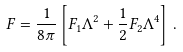<formula> <loc_0><loc_0><loc_500><loc_500>F = \frac { 1 } { 8 \pi } \left [ F _ { 1 } \Lambda ^ { 2 } + \frac { 1 } { 2 } F _ { 2 } \Lambda ^ { 4 } \right ] \, .</formula> 